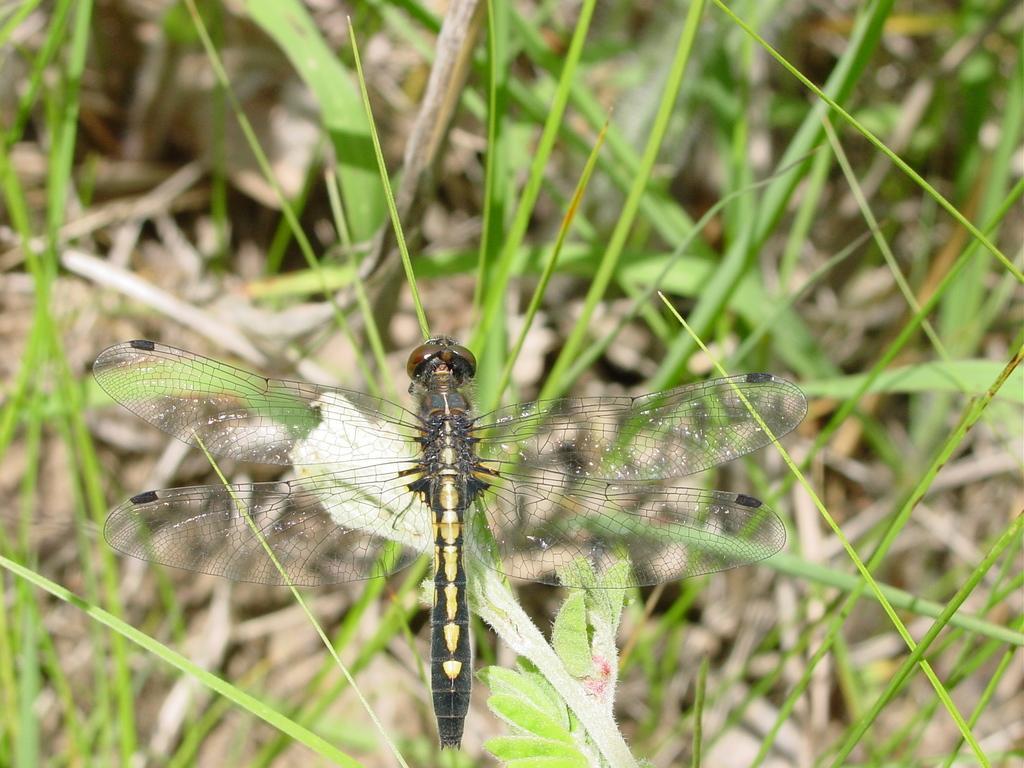Could you give a brief overview of what you see in this image? In the foreground of this image, there is a dragonfly on the leaf. In the background, there is grass. 